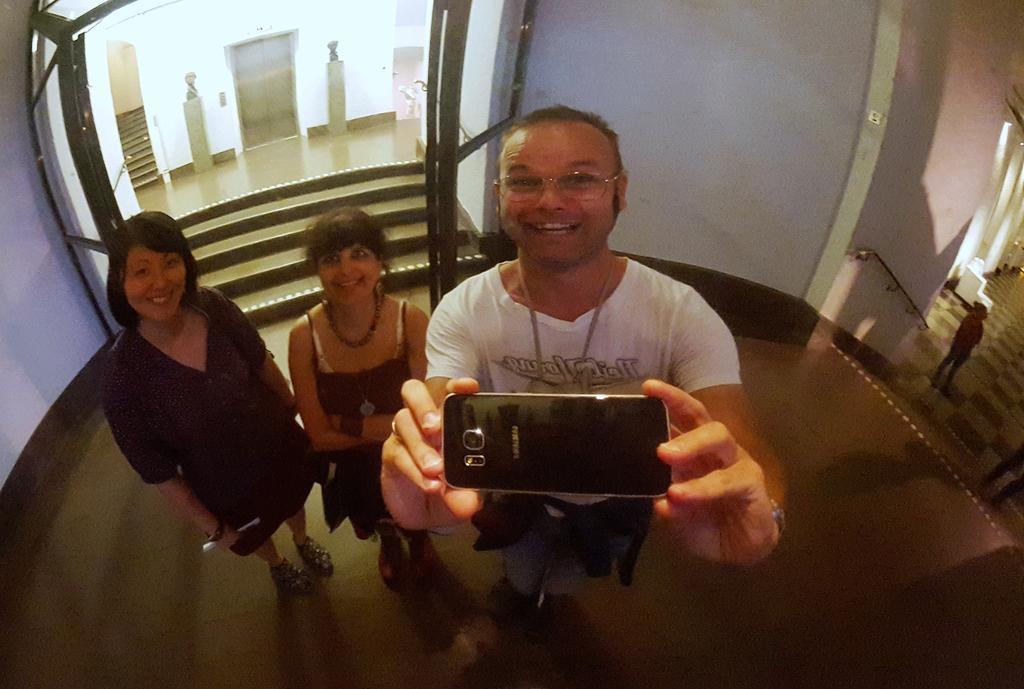Describe this image in one or two sentences. In this Image I see 2 women and a man and all of them are smiling. I can also see this man is holding a mobile. In the background I see the steps, door and the wall. 